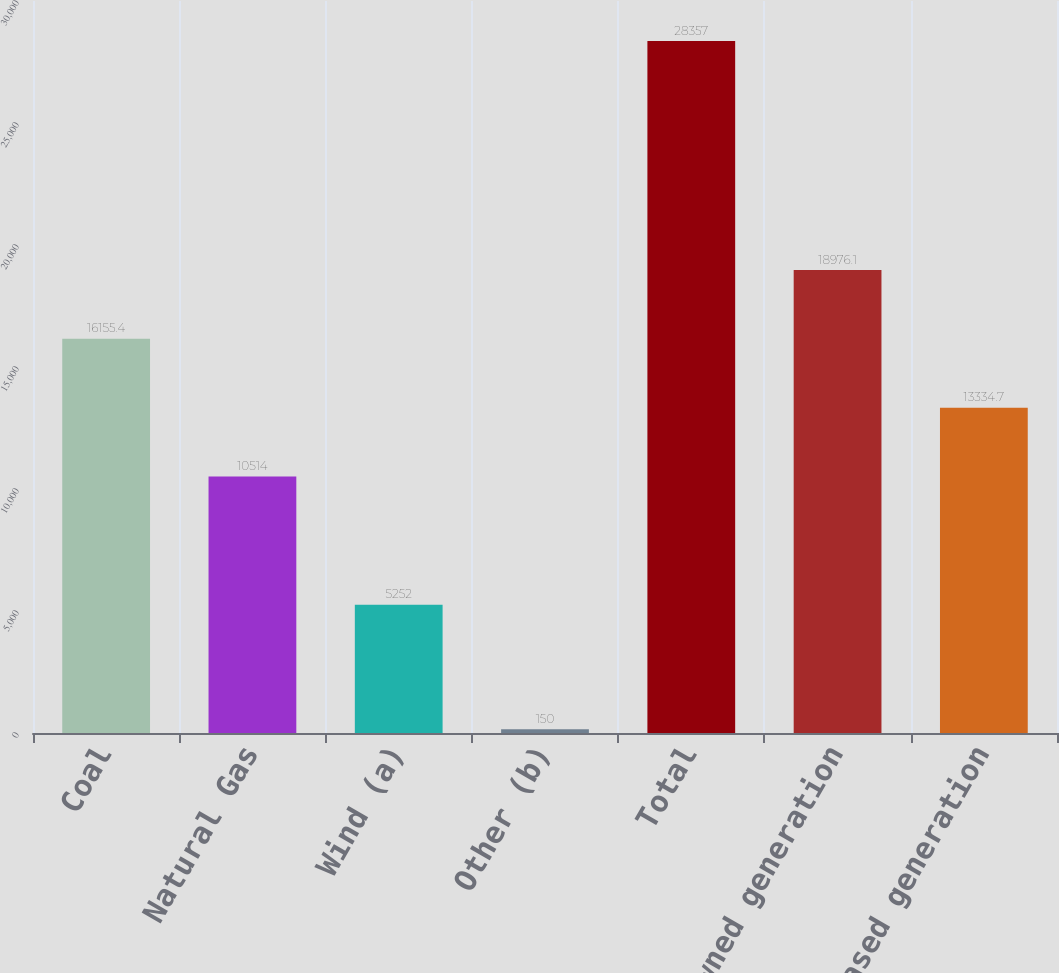Convert chart. <chart><loc_0><loc_0><loc_500><loc_500><bar_chart><fcel>Coal<fcel>Natural Gas<fcel>Wind (a)<fcel>Other (b)<fcel>Total<fcel>Owned generation<fcel>Purchased generation<nl><fcel>16155.4<fcel>10514<fcel>5252<fcel>150<fcel>28357<fcel>18976.1<fcel>13334.7<nl></chart> 